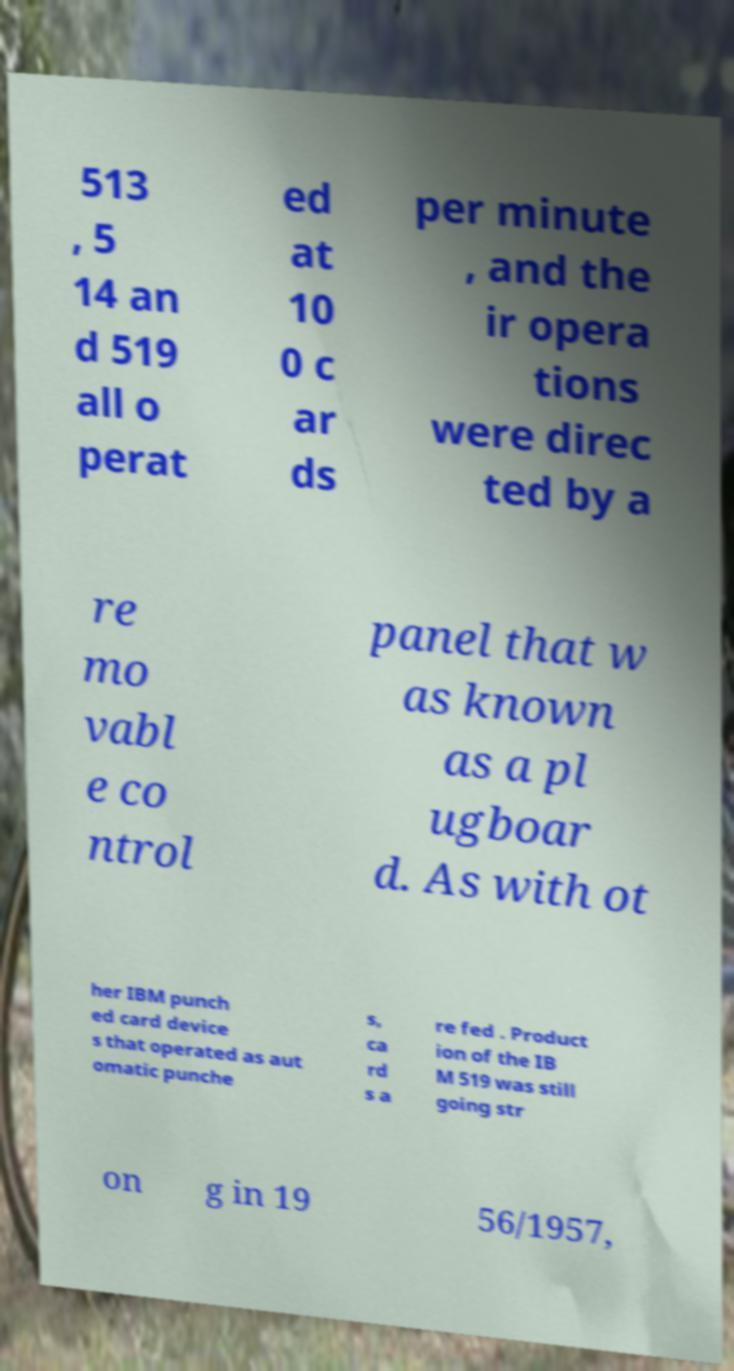Could you extract and type out the text from this image? 513 , 5 14 an d 519 all o perat ed at 10 0 c ar ds per minute , and the ir opera tions were direc ted by a re mo vabl e co ntrol panel that w as known as a pl ugboar d. As with ot her IBM punch ed card device s that operated as aut omatic punche s, ca rd s a re fed . Product ion of the IB M 519 was still going str on g in 19 56/1957, 